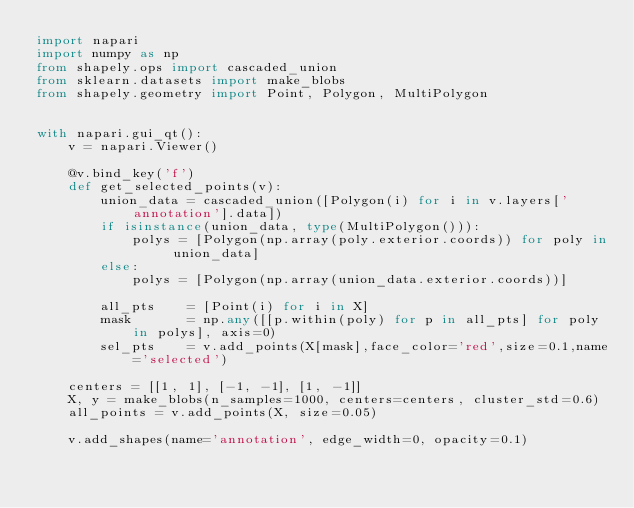Convert code to text. <code><loc_0><loc_0><loc_500><loc_500><_Python_>import napari
import numpy as np
from shapely.ops import cascaded_union
from sklearn.datasets import make_blobs
from shapely.geometry import Point, Polygon, MultiPolygon


with napari.gui_qt():
    v = napari.Viewer()

    @v.bind_key('f')
    def get_selected_points(v):
        union_data = cascaded_union([Polygon(i) for i in v.layers['annotation'].data])
        if isinstance(union_data, type(MultiPolygon())):
            polys = [Polygon(np.array(poly.exterior.coords)) for poly in union_data]
        else:
            polys = [Polygon(np.array(union_data.exterior.coords))]
        
        all_pts    = [Point(i) for i in X]
        mask       = np.any([[p.within(poly) for p in all_pts] for poly in polys], axis=0)
        sel_pts    = v.add_points(X[mask],face_color='red',size=0.1,name='selected')
        
    centers = [[1, 1], [-1, -1], [1, -1]]
    X, y = make_blobs(n_samples=1000, centers=centers, cluster_std=0.6)
    all_points = v.add_points(X, size=0.05)

    v.add_shapes(name='annotation', edge_width=0, opacity=0.1)
</code> 